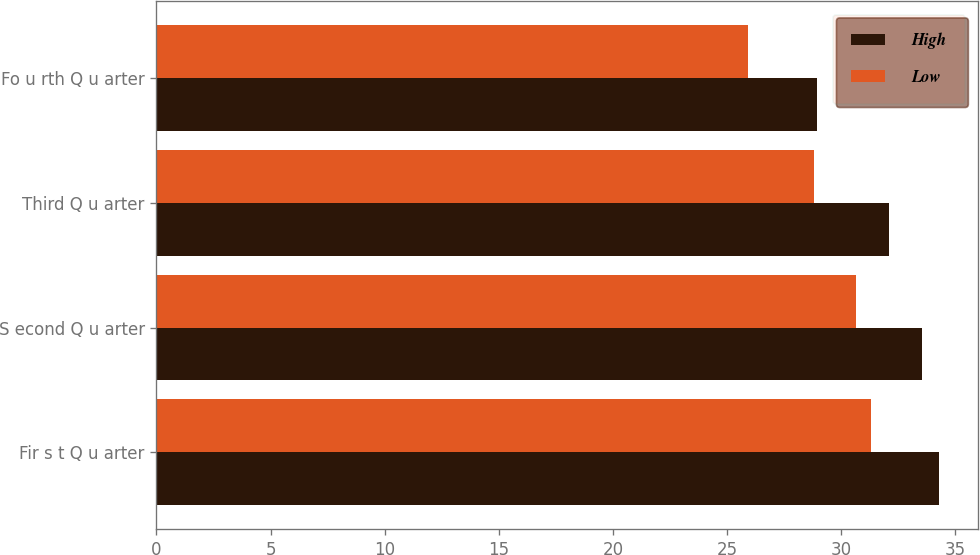Convert chart to OTSL. <chart><loc_0><loc_0><loc_500><loc_500><stacked_bar_chart><ecel><fcel>Fir s t Q u arter<fcel>S econd Q u arter<fcel>Third Q u arter<fcel>Fo u rth Q u arter<nl><fcel>High<fcel>34.3<fcel>33.53<fcel>32.1<fcel>28.94<nl><fcel>Low<fcel>31.31<fcel>30.67<fcel>28.83<fcel>25.92<nl></chart> 